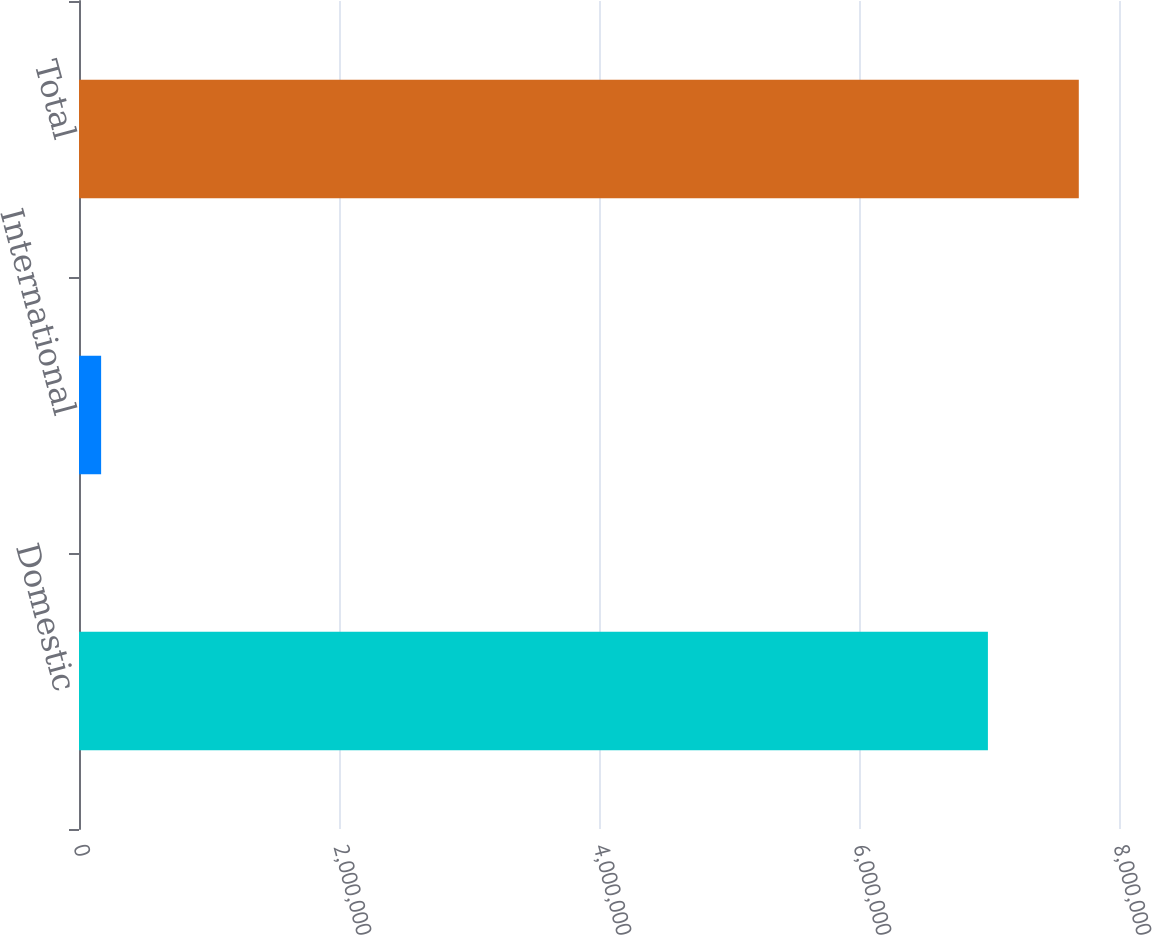Convert chart to OTSL. <chart><loc_0><loc_0><loc_500><loc_500><bar_chart><fcel>Domestic<fcel>International<fcel>Total<nl><fcel>6.99161e+06<fcel>170195<fcel>7.69078e+06<nl></chart> 